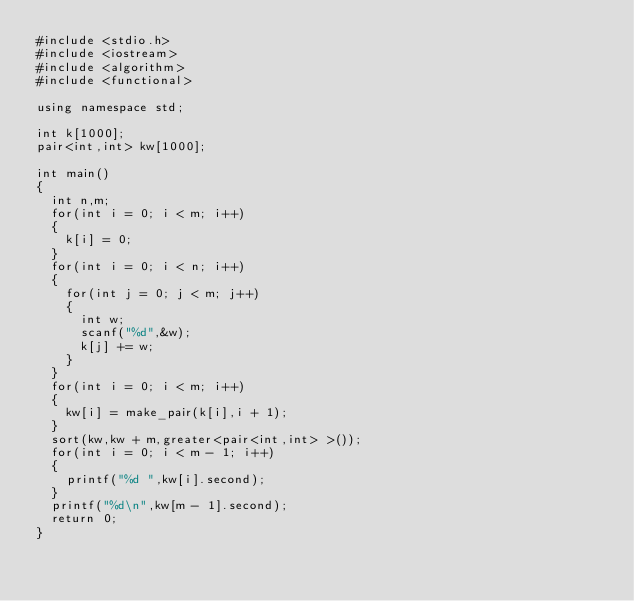<code> <loc_0><loc_0><loc_500><loc_500><_C++_>#include <stdio.h>
#include <iostream>
#include <algorithm>
#include <functional>

using namespace std;

int k[1000];
pair<int,int> kw[1000];

int main()
{
	int n,m;
	for(int i = 0; i < m; i++)
	{
		k[i] = 0;
	}
	for(int i = 0; i < n; i++)
	{
		for(int j = 0; j < m; j++)
		{
			int w;
			scanf("%d",&w);
			k[j] += w;
		}
	}
	for(int i = 0; i < m; i++)
	{
		kw[i] = make_pair(k[i],i + 1);
	}
	sort(kw,kw + m,greater<pair<int,int> >());
	for(int i = 0; i < m - 1; i++)
	{
		printf("%d ",kw[i].second);
	}
	printf("%d\n",kw[m - 1].second);
	return 0;
}</code> 